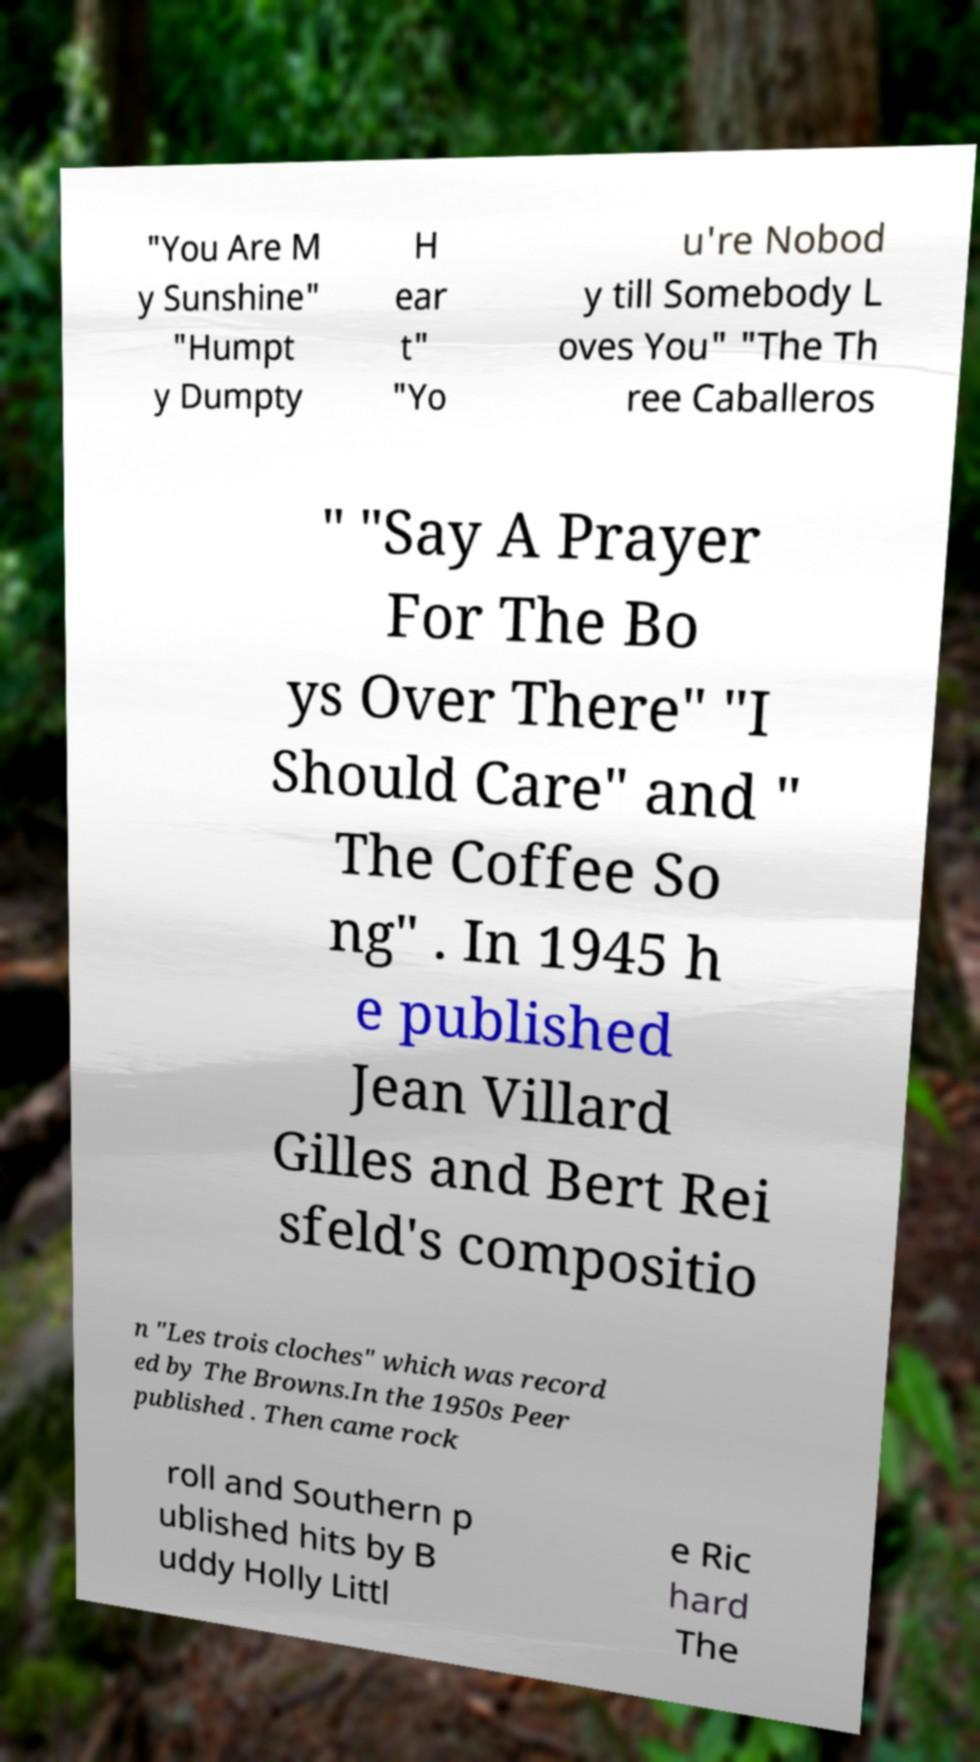I need the written content from this picture converted into text. Can you do that? "You Are M y Sunshine" "Humpt y Dumpty H ear t" "Yo u're Nobod y till Somebody L oves You" "The Th ree Caballeros " "Say A Prayer For The Bo ys Over There" "I Should Care" and " The Coffee So ng" . In 1945 h e published Jean Villard Gilles and Bert Rei sfeld's compositio n "Les trois cloches" which was record ed by The Browns.In the 1950s Peer published . Then came rock roll and Southern p ublished hits by B uddy Holly Littl e Ric hard The 